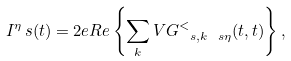Convert formula to latex. <formula><loc_0><loc_0><loc_500><loc_500>I ^ { \eta } _ { \ } s ( t ) = 2 e R e \left \{ \sum _ { k } V G _ { \ s , k \ s \eta } ^ { < } ( t , t ) \right \} ,</formula> 